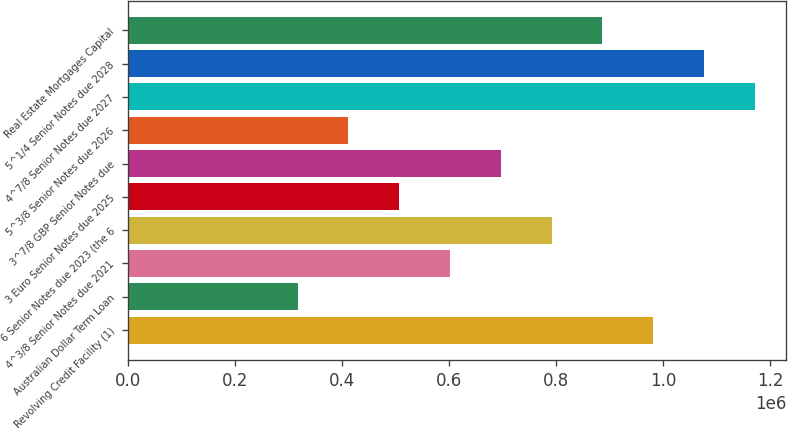Convert chart to OTSL. <chart><loc_0><loc_0><loc_500><loc_500><bar_chart><fcel>Revolving Credit Facility (1)<fcel>Australian Dollar Term Loan<fcel>4^3/8 Senior Notes due 2021<fcel>6 Senior Notes due 2023 (the 6<fcel>3 Euro Senior Notes due 2025<fcel>3^7/8 GBP Senior Notes due<fcel>5^3/8 Senior Notes due 2026<fcel>4^7/8 Senior Notes due 2027<fcel>5^1/4 Senior Notes due 2028<fcel>Real Estate Mortgages Capital<nl><fcel>981673<fcel>316673<fcel>601673<fcel>791673<fcel>506673<fcel>696673<fcel>411673<fcel>1.17167e+06<fcel>1.07667e+06<fcel>886673<nl></chart> 